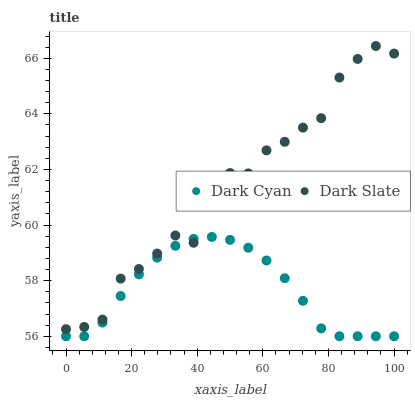Does Dark Cyan have the minimum area under the curve?
Answer yes or no. Yes. Does Dark Slate have the maximum area under the curve?
Answer yes or no. Yes. Does Dark Slate have the minimum area under the curve?
Answer yes or no. No. Is Dark Cyan the smoothest?
Answer yes or no. Yes. Is Dark Slate the roughest?
Answer yes or no. Yes. Is Dark Slate the smoothest?
Answer yes or no. No. Does Dark Cyan have the lowest value?
Answer yes or no. Yes. Does Dark Slate have the lowest value?
Answer yes or no. No. Does Dark Slate have the highest value?
Answer yes or no. Yes. Does Dark Slate intersect Dark Cyan?
Answer yes or no. Yes. Is Dark Slate less than Dark Cyan?
Answer yes or no. No. Is Dark Slate greater than Dark Cyan?
Answer yes or no. No. 